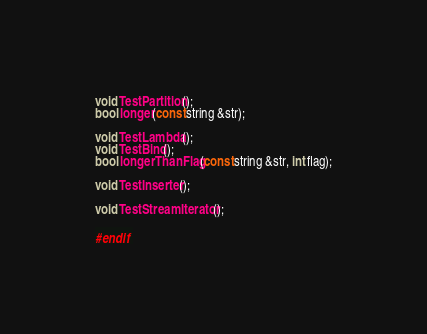<code> <loc_0><loc_0><loc_500><loc_500><_C++_>
void TestPartition();
bool longer(const string &str);

void TestLambda();
void TestBind();
bool longerThanFlag(const string &str, int flag);

void TestInserter();

void TestStreamIterator();

#endif</code> 